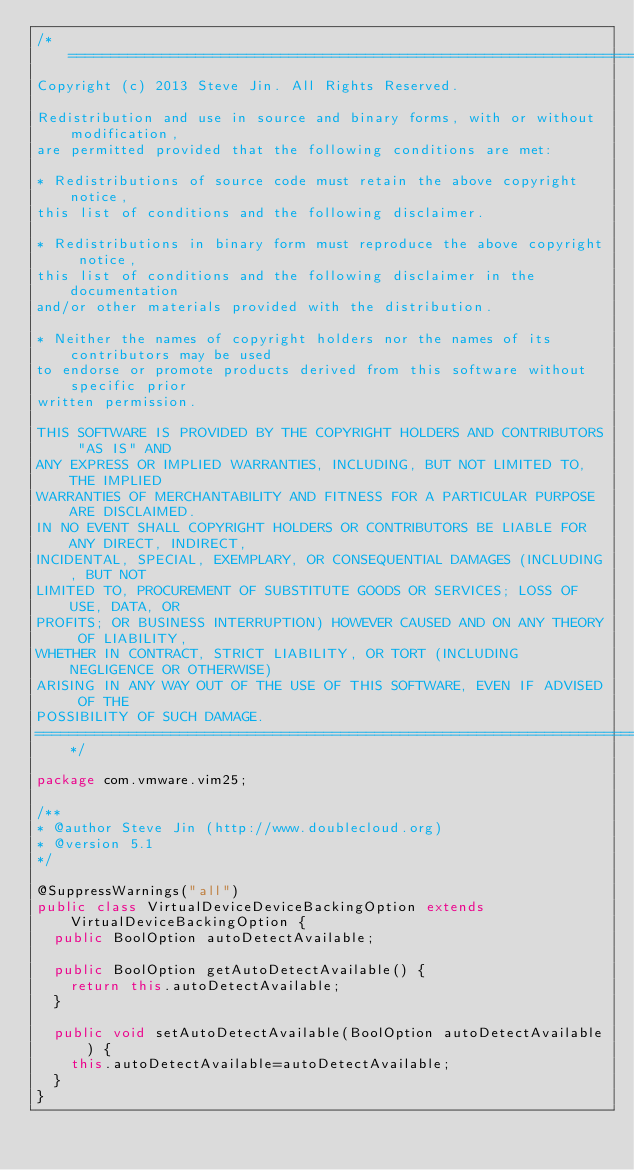<code> <loc_0><loc_0><loc_500><loc_500><_Java_>/*================================================================================
Copyright (c) 2013 Steve Jin. All Rights Reserved.

Redistribution and use in source and binary forms, with or without modification, 
are permitted provided that the following conditions are met:

* Redistributions of source code must retain the above copyright notice, 
this list of conditions and the following disclaimer.

* Redistributions in binary form must reproduce the above copyright notice, 
this list of conditions and the following disclaimer in the documentation 
and/or other materials provided with the distribution.

* Neither the names of copyright holders nor the names of its contributors may be used
to endorse or promote products derived from this software without specific prior 
written permission.

THIS SOFTWARE IS PROVIDED BY THE COPYRIGHT HOLDERS AND CONTRIBUTORS "AS IS" AND 
ANY EXPRESS OR IMPLIED WARRANTIES, INCLUDING, BUT NOT LIMITED TO, THE IMPLIED 
WARRANTIES OF MERCHANTABILITY AND FITNESS FOR A PARTICULAR PURPOSE ARE DISCLAIMED. 
IN NO EVENT SHALL COPYRIGHT HOLDERS OR CONTRIBUTORS BE LIABLE FOR ANY DIRECT, INDIRECT, 
INCIDENTAL, SPECIAL, EXEMPLARY, OR CONSEQUENTIAL DAMAGES (INCLUDING, BUT NOT 
LIMITED TO, PROCUREMENT OF SUBSTITUTE GOODS OR SERVICES; LOSS OF USE, DATA, OR 
PROFITS; OR BUSINESS INTERRUPTION) HOWEVER CAUSED AND ON ANY THEORY OF LIABILITY, 
WHETHER IN CONTRACT, STRICT LIABILITY, OR TORT (INCLUDING NEGLIGENCE OR OTHERWISE) 
ARISING IN ANY WAY OUT OF THE USE OF THIS SOFTWARE, EVEN IF ADVISED OF THE 
POSSIBILITY OF SUCH DAMAGE.
================================================================================*/

package com.vmware.vim25;

/**
* @author Steve Jin (http://www.doublecloud.org)
* @version 5.1
*/

@SuppressWarnings("all")
public class VirtualDeviceDeviceBackingOption extends VirtualDeviceBackingOption {
  public BoolOption autoDetectAvailable;

  public BoolOption getAutoDetectAvailable() {
    return this.autoDetectAvailable;
  }

  public void setAutoDetectAvailable(BoolOption autoDetectAvailable) {
    this.autoDetectAvailable=autoDetectAvailable;
  }
}</code> 